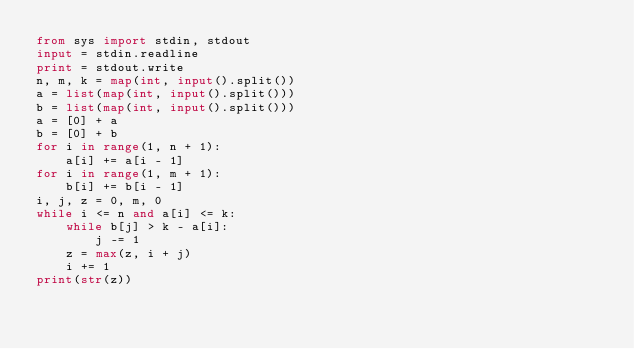Convert code to text. <code><loc_0><loc_0><loc_500><loc_500><_Python_>from sys import stdin, stdout
input = stdin.readline
print = stdout.write
n, m, k = map(int, input().split())
a = list(map(int, input().split()))
b = list(map(int, input().split()))
a = [0] + a
b = [0] + b
for i in range(1, n + 1):
    a[i] += a[i - 1]
for i in range(1, m + 1):
    b[i] += b[i - 1]
i, j, z = 0, m, 0
while i <= n and a[i] <= k:
    while b[j] > k - a[i]:
        j -= 1
    z = max(z, i + j)
    i += 1
print(str(z))</code> 